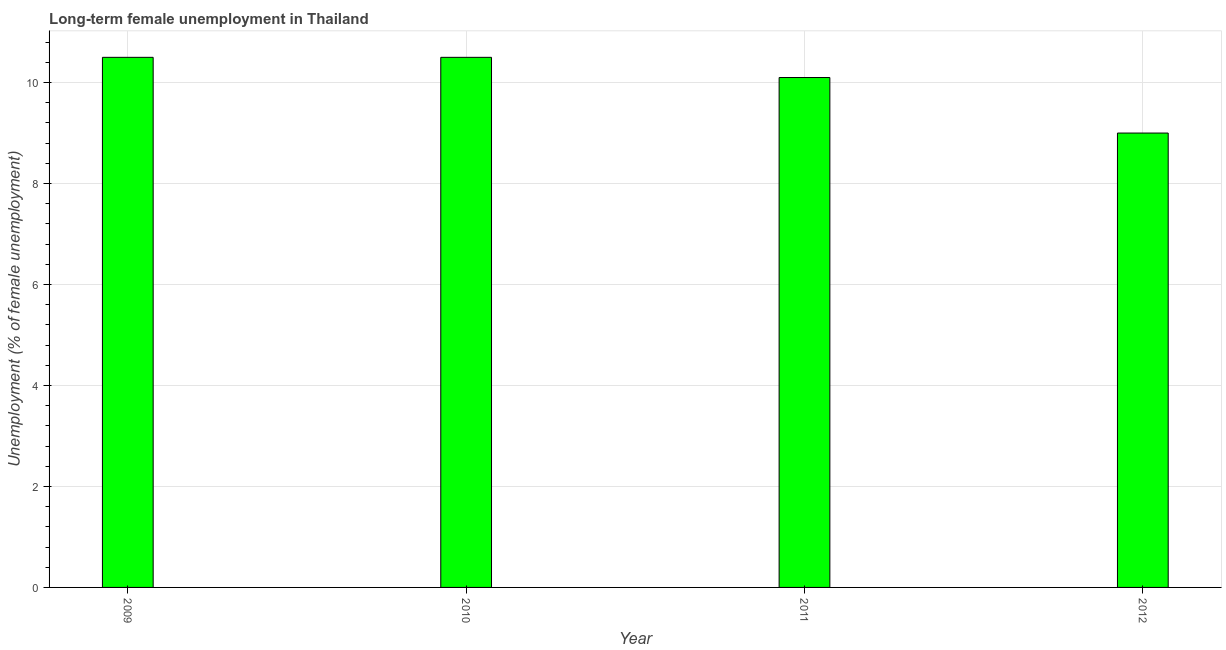Does the graph contain grids?
Make the answer very short. Yes. What is the title of the graph?
Provide a short and direct response. Long-term female unemployment in Thailand. What is the label or title of the X-axis?
Make the answer very short. Year. What is the label or title of the Y-axis?
Make the answer very short. Unemployment (% of female unemployment). What is the long-term female unemployment in 2010?
Your answer should be compact. 10.5. Across all years, what is the maximum long-term female unemployment?
Provide a short and direct response. 10.5. Across all years, what is the minimum long-term female unemployment?
Provide a succinct answer. 9. What is the sum of the long-term female unemployment?
Provide a succinct answer. 40.1. What is the average long-term female unemployment per year?
Your answer should be very brief. 10.03. What is the median long-term female unemployment?
Your answer should be very brief. 10.3. In how many years, is the long-term female unemployment greater than 2 %?
Offer a terse response. 4. What is the ratio of the long-term female unemployment in 2009 to that in 2011?
Provide a short and direct response. 1.04. Is the long-term female unemployment in 2010 less than that in 2012?
Provide a short and direct response. No. Is the sum of the long-term female unemployment in 2011 and 2012 greater than the maximum long-term female unemployment across all years?
Provide a short and direct response. Yes. In how many years, is the long-term female unemployment greater than the average long-term female unemployment taken over all years?
Provide a short and direct response. 3. Are all the bars in the graph horizontal?
Offer a very short reply. No. How many years are there in the graph?
Offer a very short reply. 4. Are the values on the major ticks of Y-axis written in scientific E-notation?
Ensure brevity in your answer.  No. What is the Unemployment (% of female unemployment) in 2009?
Offer a terse response. 10.5. What is the Unemployment (% of female unemployment) of 2010?
Provide a succinct answer. 10.5. What is the Unemployment (% of female unemployment) of 2011?
Your answer should be very brief. 10.1. What is the difference between the Unemployment (% of female unemployment) in 2009 and 2011?
Offer a very short reply. 0.4. What is the difference between the Unemployment (% of female unemployment) in 2009 and 2012?
Offer a terse response. 1.5. What is the difference between the Unemployment (% of female unemployment) in 2011 and 2012?
Offer a terse response. 1.1. What is the ratio of the Unemployment (% of female unemployment) in 2009 to that in 2011?
Offer a very short reply. 1.04. What is the ratio of the Unemployment (% of female unemployment) in 2009 to that in 2012?
Offer a terse response. 1.17. What is the ratio of the Unemployment (% of female unemployment) in 2010 to that in 2011?
Your answer should be compact. 1.04. What is the ratio of the Unemployment (% of female unemployment) in 2010 to that in 2012?
Offer a very short reply. 1.17. What is the ratio of the Unemployment (% of female unemployment) in 2011 to that in 2012?
Keep it short and to the point. 1.12. 